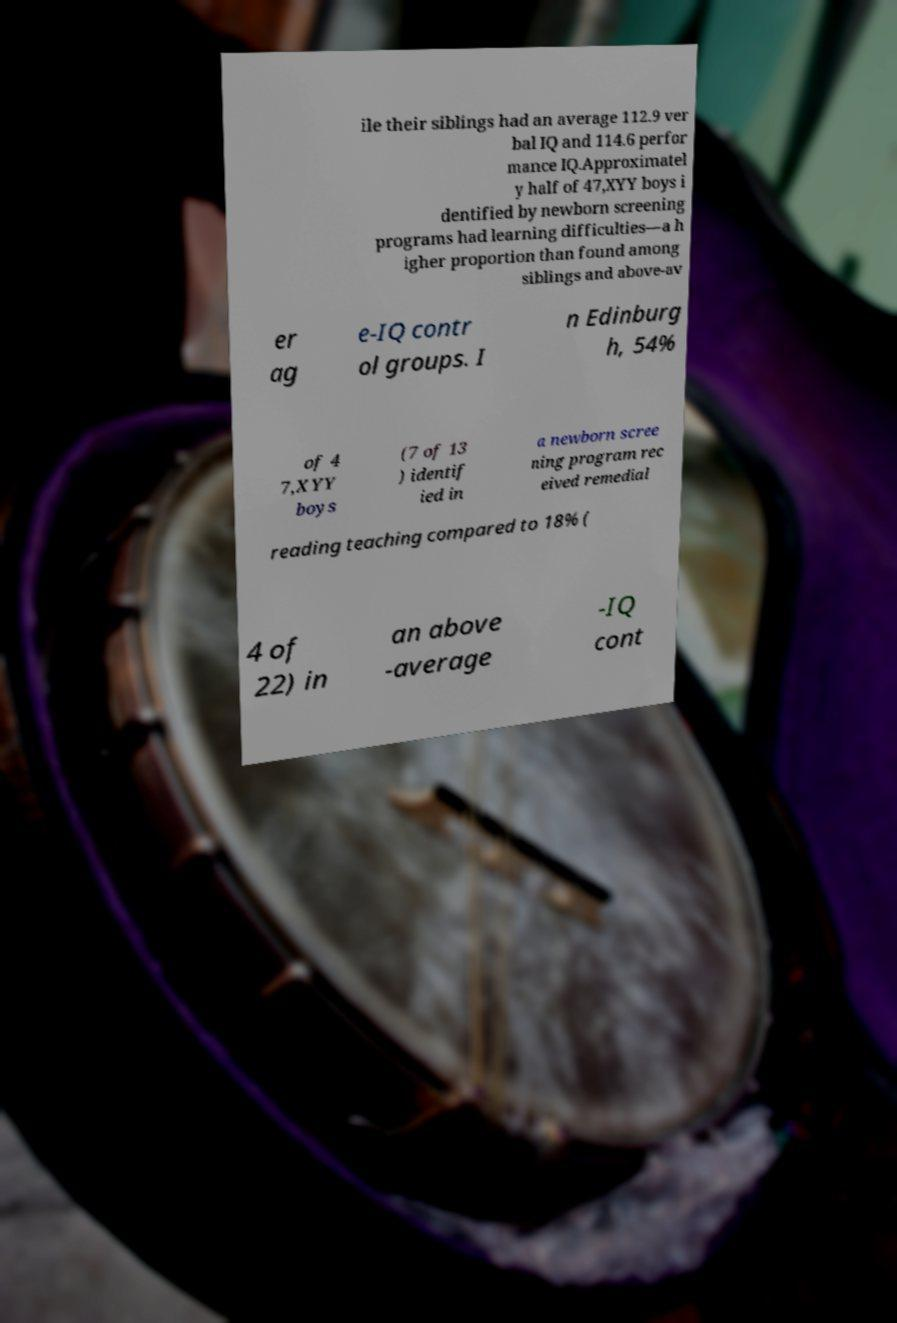For documentation purposes, I need the text within this image transcribed. Could you provide that? ile their siblings had an average 112.9 ver bal IQ and 114.6 perfor mance IQ.Approximatel y half of 47,XYY boys i dentified by newborn screening programs had learning difficulties—a h igher proportion than found among siblings and above-av er ag e-IQ contr ol groups. I n Edinburg h, 54% of 4 7,XYY boys (7 of 13 ) identif ied in a newborn scree ning program rec eived remedial reading teaching compared to 18% ( 4 of 22) in an above -average -IQ cont 